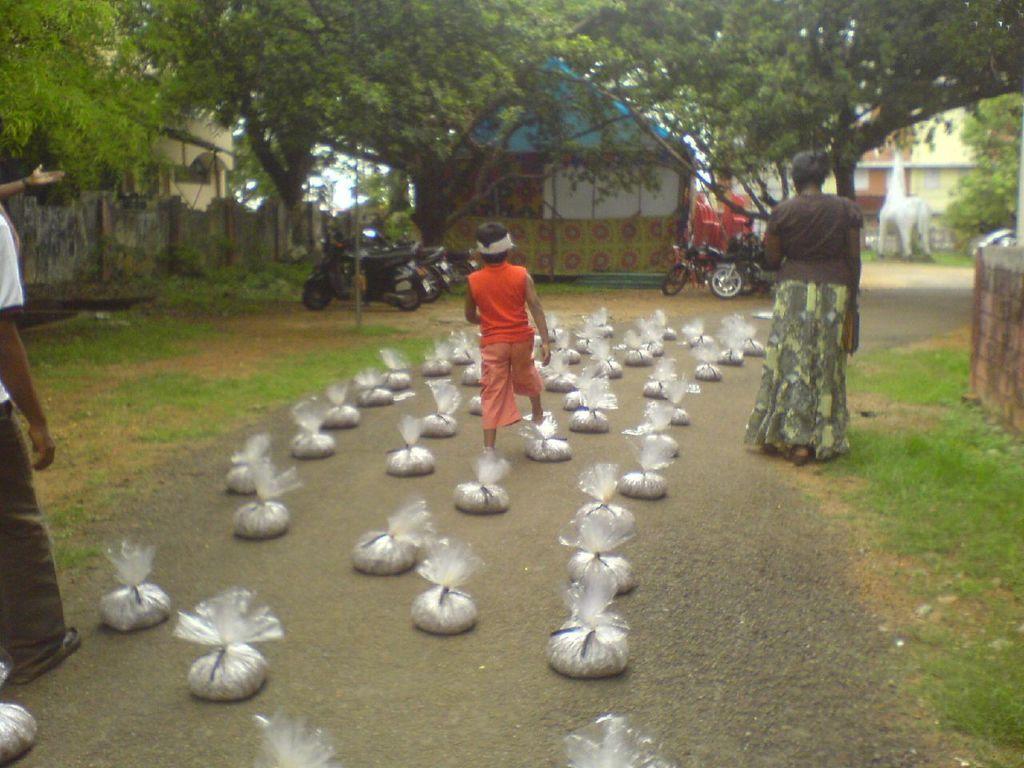Can you describe this image briefly? In this picture I can see people standing on the road and some white color objects on the road. In the background I can see vehicles, house, buildings, trees and grass. On the left side I can see wall. 